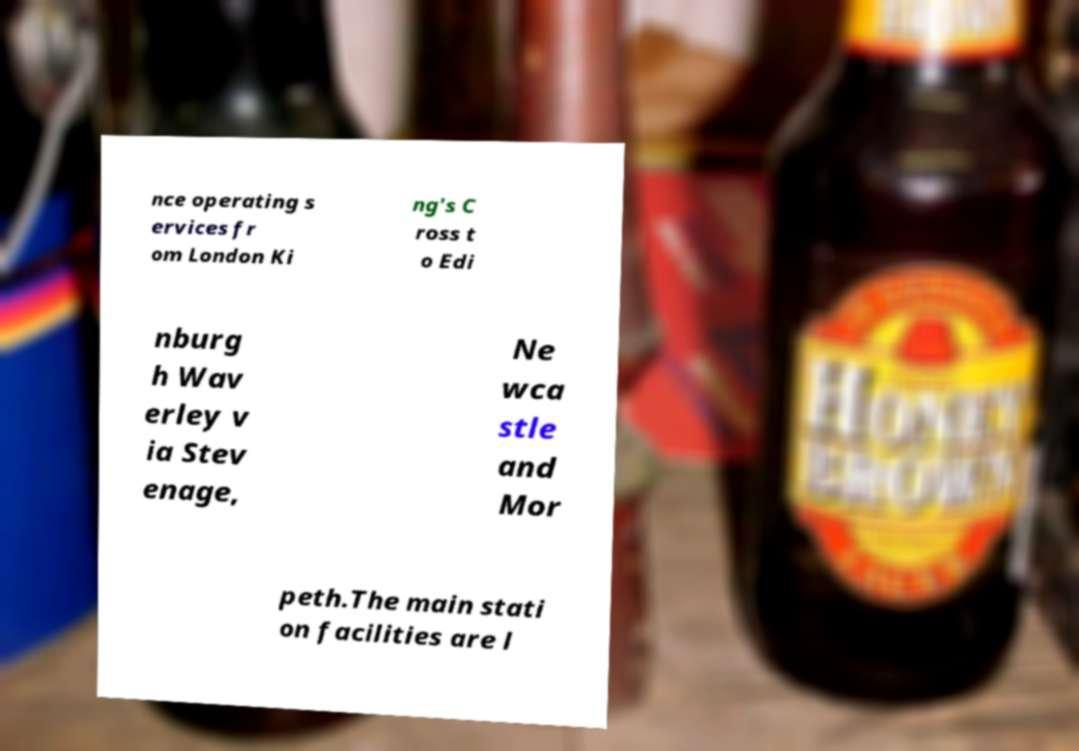Please read and relay the text visible in this image. What does it say? nce operating s ervices fr om London Ki ng's C ross t o Edi nburg h Wav erley v ia Stev enage, Ne wca stle and Mor peth.The main stati on facilities are l 